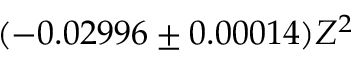<formula> <loc_0><loc_0><loc_500><loc_500>( - 0 . 0 2 9 9 6 \pm 0 . 0 0 0 1 4 ) Z ^ { 2 }</formula> 